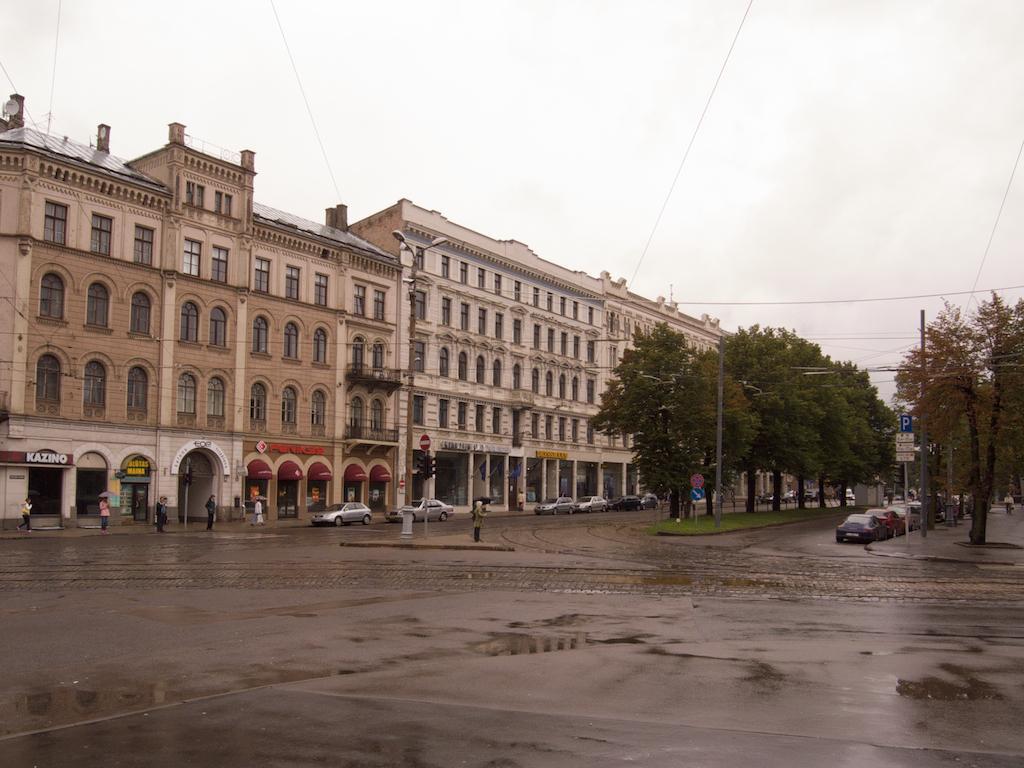How would you summarize this image in a sentence or two? In this image, we can see a few buildings, glass windows, walls, pillars, trees, hoardings, poles, lights. At the bottom, we can see roads. Few vehicles are there on the roads. Here we can see few people, sign boards. Top of the image, there is a sky and wires. 